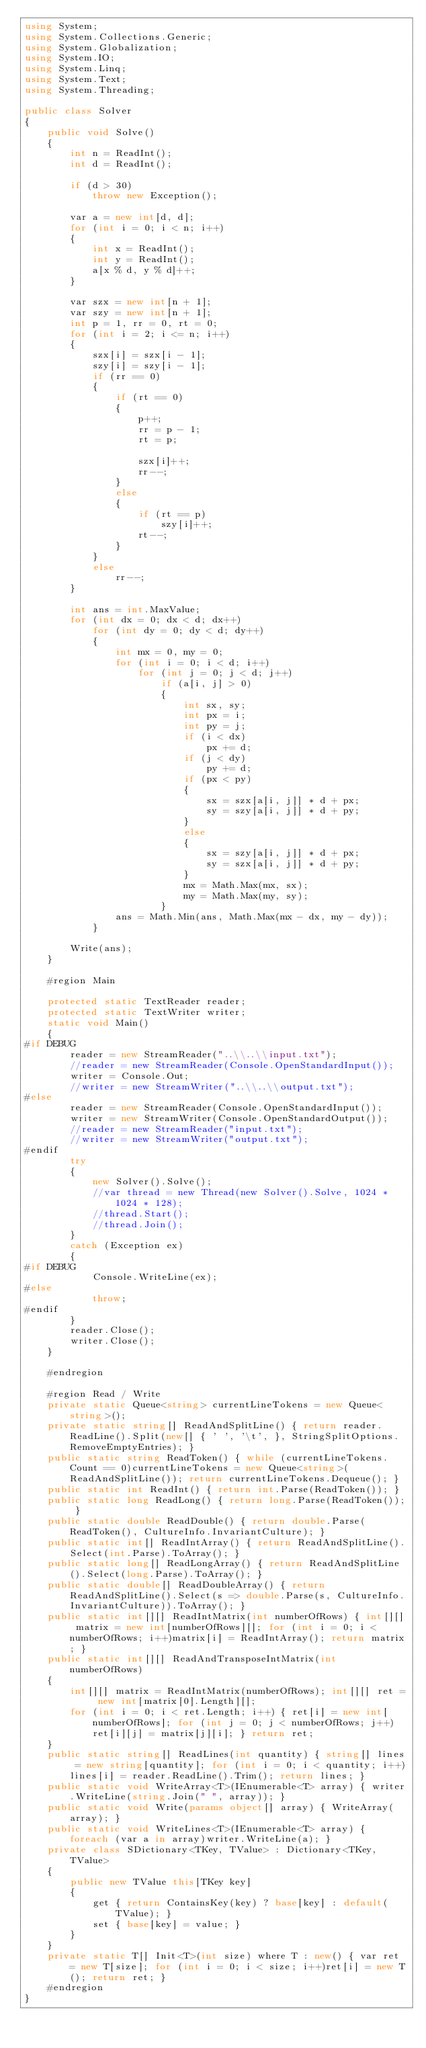Convert code to text. <code><loc_0><loc_0><loc_500><loc_500><_C#_>using System;
using System.Collections.Generic;
using System.Globalization;
using System.IO;
using System.Linq;
using System.Text;
using System.Threading;

public class Solver
{
    public void Solve()
    {
        int n = ReadInt();
        int d = ReadInt();

        if (d > 30)
            throw new Exception();

        var a = new int[d, d];
        for (int i = 0; i < n; i++)
        {
            int x = ReadInt();
            int y = ReadInt();
            a[x % d, y % d]++;
        }

        var szx = new int[n + 1];
        var szy = new int[n + 1];
        int p = 1, rr = 0, rt = 0;
        for (int i = 2; i <= n; i++)
        {
            szx[i] = szx[i - 1];
            szy[i] = szy[i - 1];
            if (rr == 0)
            {
                if (rt == 0)
                {
                    p++;
                    rr = p - 1;
                    rt = p;

                    szx[i]++;
                    rr--;
                }
                else
                {
                    if (rt == p)
                        szy[i]++;
                    rt--;
                }
            }
            else
                rr--;
        }

        int ans = int.MaxValue;
        for (int dx = 0; dx < d; dx++)
            for (int dy = 0; dy < d; dy++)
            {
                int mx = 0, my = 0;
                for (int i = 0; i < d; i++)
                    for (int j = 0; j < d; j++)
                        if (a[i, j] > 0)
                        {
                            int sx, sy;
                            int px = i;
                            int py = j;
                            if (i < dx)
                                px += d;
                            if (j < dy)
                                py += d;
                            if (px < py)
                            {
                                sx = szx[a[i, j]] * d + px;
                                sy = szy[a[i, j]] * d + py;
                            }
                            else
                            {
                                sx = szy[a[i, j]] * d + px;
                                sy = szx[a[i, j]] * d + py;
                            }
                            mx = Math.Max(mx, sx);
                            my = Math.Max(my, sy);
                        }
                ans = Math.Min(ans, Math.Max(mx - dx, my - dy));
            }

        Write(ans);
    }

    #region Main

    protected static TextReader reader;
    protected static TextWriter writer;
    static void Main()
    {
#if DEBUG
        reader = new StreamReader("..\\..\\input.txt");
        //reader = new StreamReader(Console.OpenStandardInput());
        writer = Console.Out;
        //writer = new StreamWriter("..\\..\\output.txt");
#else
        reader = new StreamReader(Console.OpenStandardInput());
        writer = new StreamWriter(Console.OpenStandardOutput());
        //reader = new StreamReader("input.txt");
        //writer = new StreamWriter("output.txt");
#endif
        try
        {
            new Solver().Solve();
            //var thread = new Thread(new Solver().Solve, 1024 * 1024 * 128);
            //thread.Start();
            //thread.Join();
        }
        catch (Exception ex)
        {
#if DEBUG
            Console.WriteLine(ex);
#else
            throw;
#endif
        }
        reader.Close();
        writer.Close();
    }

    #endregion

    #region Read / Write
    private static Queue<string> currentLineTokens = new Queue<string>();
    private static string[] ReadAndSplitLine() { return reader.ReadLine().Split(new[] { ' ', '\t', }, StringSplitOptions.RemoveEmptyEntries); }
    public static string ReadToken() { while (currentLineTokens.Count == 0)currentLineTokens = new Queue<string>(ReadAndSplitLine()); return currentLineTokens.Dequeue(); }
    public static int ReadInt() { return int.Parse(ReadToken()); }
    public static long ReadLong() { return long.Parse(ReadToken()); }
    public static double ReadDouble() { return double.Parse(ReadToken(), CultureInfo.InvariantCulture); }
    public static int[] ReadIntArray() { return ReadAndSplitLine().Select(int.Parse).ToArray(); }
    public static long[] ReadLongArray() { return ReadAndSplitLine().Select(long.Parse).ToArray(); }
    public static double[] ReadDoubleArray() { return ReadAndSplitLine().Select(s => double.Parse(s, CultureInfo.InvariantCulture)).ToArray(); }
    public static int[][] ReadIntMatrix(int numberOfRows) { int[][] matrix = new int[numberOfRows][]; for (int i = 0; i < numberOfRows; i++)matrix[i] = ReadIntArray(); return matrix; }
    public static int[][] ReadAndTransposeIntMatrix(int numberOfRows)
    {
        int[][] matrix = ReadIntMatrix(numberOfRows); int[][] ret = new int[matrix[0].Length][];
        for (int i = 0; i < ret.Length; i++) { ret[i] = new int[numberOfRows]; for (int j = 0; j < numberOfRows; j++)ret[i][j] = matrix[j][i]; } return ret;
    }
    public static string[] ReadLines(int quantity) { string[] lines = new string[quantity]; for (int i = 0; i < quantity; i++)lines[i] = reader.ReadLine().Trim(); return lines; }
    public static void WriteArray<T>(IEnumerable<T> array) { writer.WriteLine(string.Join(" ", array)); }
    public static void Write(params object[] array) { WriteArray(array); }
    public static void WriteLines<T>(IEnumerable<T> array) { foreach (var a in array)writer.WriteLine(a); }
    private class SDictionary<TKey, TValue> : Dictionary<TKey, TValue>
    {
        public new TValue this[TKey key]
        {
            get { return ContainsKey(key) ? base[key] : default(TValue); }
            set { base[key] = value; }
        }
    }
    private static T[] Init<T>(int size) where T : new() { var ret = new T[size]; for (int i = 0; i < size; i++)ret[i] = new T(); return ret; }
    #endregion
}</code> 